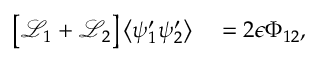Convert formula to latex. <formula><loc_0><loc_0><loc_500><loc_500>\begin{array} { r l } { \left [ \mathcal { L } _ { 1 } + \mathcal { L } _ { 2 } \right ] \left \langle \psi _ { 1 } ^ { \prime } \psi _ { 2 } ^ { \prime } \right \rangle } & = 2 \epsilon \Phi _ { 1 2 } , } \end{array}</formula> 